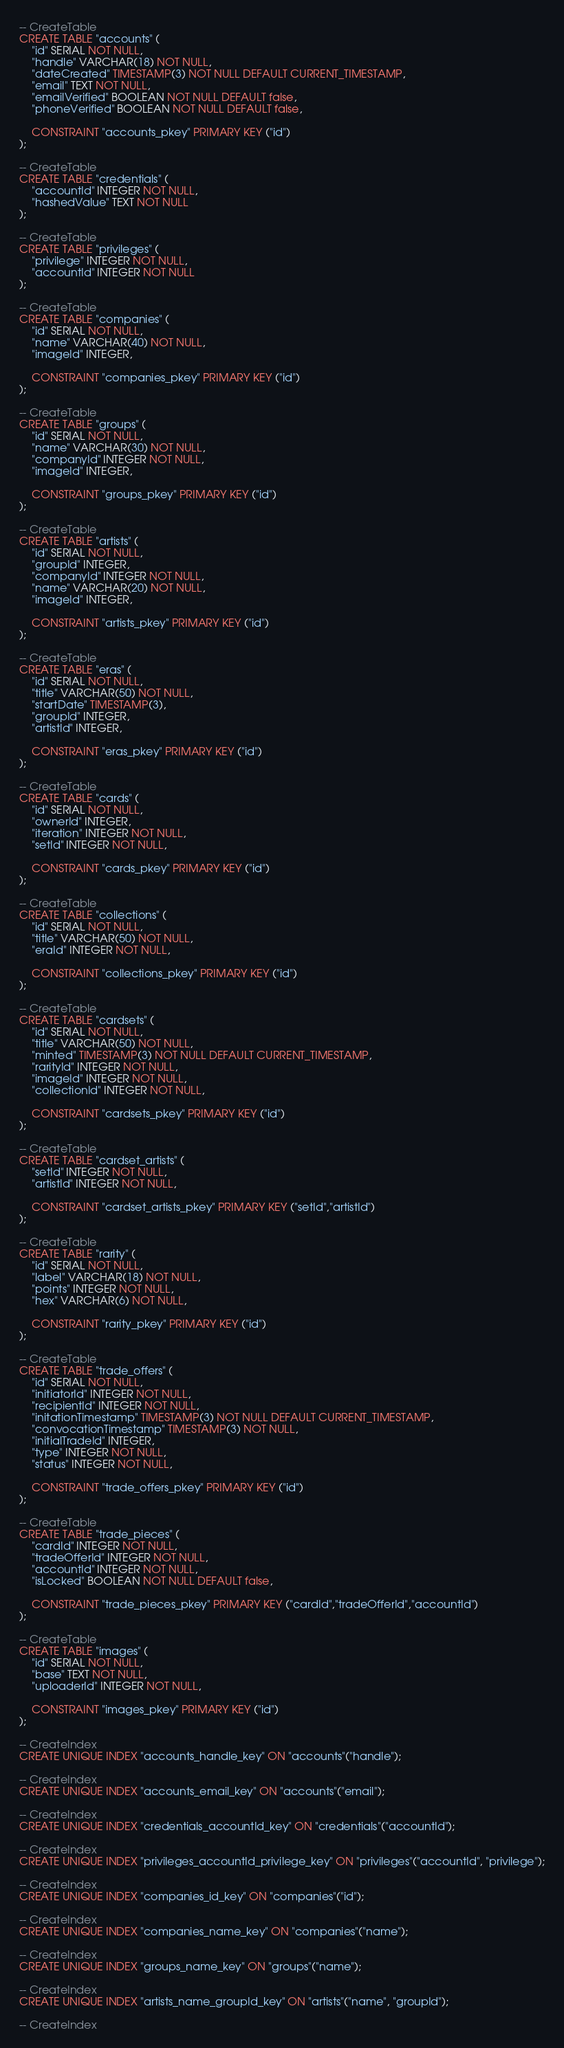<code> <loc_0><loc_0><loc_500><loc_500><_SQL_>-- CreateTable
CREATE TABLE "accounts" (
    "id" SERIAL NOT NULL,
    "handle" VARCHAR(18) NOT NULL,
    "dateCreated" TIMESTAMP(3) NOT NULL DEFAULT CURRENT_TIMESTAMP,
    "email" TEXT NOT NULL,
    "emailVerified" BOOLEAN NOT NULL DEFAULT false,
    "phoneVerified" BOOLEAN NOT NULL DEFAULT false,

    CONSTRAINT "accounts_pkey" PRIMARY KEY ("id")
);

-- CreateTable
CREATE TABLE "credentials" (
    "accountId" INTEGER NOT NULL,
    "hashedValue" TEXT NOT NULL
);

-- CreateTable
CREATE TABLE "privileges" (
    "privilege" INTEGER NOT NULL,
    "accountId" INTEGER NOT NULL
);

-- CreateTable
CREATE TABLE "companies" (
    "id" SERIAL NOT NULL,
    "name" VARCHAR(40) NOT NULL,
    "imageId" INTEGER,

    CONSTRAINT "companies_pkey" PRIMARY KEY ("id")
);

-- CreateTable
CREATE TABLE "groups" (
    "id" SERIAL NOT NULL,
    "name" VARCHAR(30) NOT NULL,
    "companyId" INTEGER NOT NULL,
    "imageId" INTEGER,

    CONSTRAINT "groups_pkey" PRIMARY KEY ("id")
);

-- CreateTable
CREATE TABLE "artists" (
    "id" SERIAL NOT NULL,
    "groupId" INTEGER,
    "companyId" INTEGER NOT NULL,
    "name" VARCHAR(20) NOT NULL,
    "imageId" INTEGER,

    CONSTRAINT "artists_pkey" PRIMARY KEY ("id")
);

-- CreateTable
CREATE TABLE "eras" (
    "id" SERIAL NOT NULL,
    "title" VARCHAR(50) NOT NULL,
    "startDate" TIMESTAMP(3),
    "groupId" INTEGER,
    "artistId" INTEGER,

    CONSTRAINT "eras_pkey" PRIMARY KEY ("id")
);

-- CreateTable
CREATE TABLE "cards" (
    "id" SERIAL NOT NULL,
    "ownerId" INTEGER,
    "iteration" INTEGER NOT NULL,
    "setId" INTEGER NOT NULL,

    CONSTRAINT "cards_pkey" PRIMARY KEY ("id")
);

-- CreateTable
CREATE TABLE "collections" (
    "id" SERIAL NOT NULL,
    "title" VARCHAR(50) NOT NULL,
    "eraId" INTEGER NOT NULL,

    CONSTRAINT "collections_pkey" PRIMARY KEY ("id")
);

-- CreateTable
CREATE TABLE "cardsets" (
    "id" SERIAL NOT NULL,
    "title" VARCHAR(50) NOT NULL,
    "minted" TIMESTAMP(3) NOT NULL DEFAULT CURRENT_TIMESTAMP,
    "rarityId" INTEGER NOT NULL,
    "imageId" INTEGER NOT NULL,
    "collectionId" INTEGER NOT NULL,

    CONSTRAINT "cardsets_pkey" PRIMARY KEY ("id")
);

-- CreateTable
CREATE TABLE "cardset_artists" (
    "setId" INTEGER NOT NULL,
    "artistId" INTEGER NOT NULL,

    CONSTRAINT "cardset_artists_pkey" PRIMARY KEY ("setId","artistId")
);

-- CreateTable
CREATE TABLE "rarity" (
    "id" SERIAL NOT NULL,
    "label" VARCHAR(18) NOT NULL,
    "points" INTEGER NOT NULL,
    "hex" VARCHAR(6) NOT NULL,

    CONSTRAINT "rarity_pkey" PRIMARY KEY ("id")
);

-- CreateTable
CREATE TABLE "trade_offers" (
    "id" SERIAL NOT NULL,
    "initiatorId" INTEGER NOT NULL,
    "recipientId" INTEGER NOT NULL,
    "initationTimestamp" TIMESTAMP(3) NOT NULL DEFAULT CURRENT_TIMESTAMP,
    "convocationTimestamp" TIMESTAMP(3) NOT NULL,
    "initialTradeId" INTEGER,
    "type" INTEGER NOT NULL,
    "status" INTEGER NOT NULL,

    CONSTRAINT "trade_offers_pkey" PRIMARY KEY ("id")
);

-- CreateTable
CREATE TABLE "trade_pieces" (
    "cardId" INTEGER NOT NULL,
    "tradeOfferId" INTEGER NOT NULL,
    "accountId" INTEGER NOT NULL,
    "isLocked" BOOLEAN NOT NULL DEFAULT false,

    CONSTRAINT "trade_pieces_pkey" PRIMARY KEY ("cardId","tradeOfferId","accountId")
);

-- CreateTable
CREATE TABLE "images" (
    "id" SERIAL NOT NULL,
    "base" TEXT NOT NULL,
    "uploaderId" INTEGER NOT NULL,

    CONSTRAINT "images_pkey" PRIMARY KEY ("id")
);

-- CreateIndex
CREATE UNIQUE INDEX "accounts_handle_key" ON "accounts"("handle");

-- CreateIndex
CREATE UNIQUE INDEX "accounts_email_key" ON "accounts"("email");

-- CreateIndex
CREATE UNIQUE INDEX "credentials_accountId_key" ON "credentials"("accountId");

-- CreateIndex
CREATE UNIQUE INDEX "privileges_accountId_privilege_key" ON "privileges"("accountId", "privilege");

-- CreateIndex
CREATE UNIQUE INDEX "companies_id_key" ON "companies"("id");

-- CreateIndex
CREATE UNIQUE INDEX "companies_name_key" ON "companies"("name");

-- CreateIndex
CREATE UNIQUE INDEX "groups_name_key" ON "groups"("name");

-- CreateIndex
CREATE UNIQUE INDEX "artists_name_groupId_key" ON "artists"("name", "groupId");

-- CreateIndex</code> 